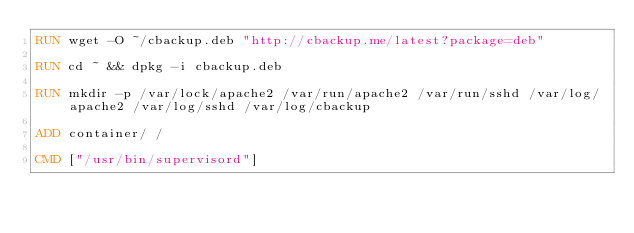<code> <loc_0><loc_0><loc_500><loc_500><_Dockerfile_>RUN wget -O ~/cbackup.deb "http://cbackup.me/latest?package=deb"

RUN cd ~ && dpkg -i cbackup.deb

RUN mkdir -p /var/lock/apache2 /var/run/apache2 /var/run/sshd /var/log/apache2 /var/log/sshd /var/log/cbackup

ADD container/ /

CMD ["/usr/bin/supervisord"]

</code> 